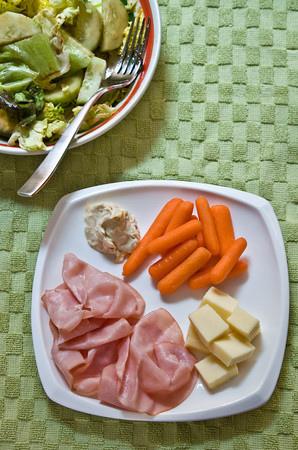Does this plate have bread?
Be succinct. No. Which item represents the dairy food group?
Concise answer only. Cheese. Is this lunch, or dinner?
Short answer required. Lunch. 